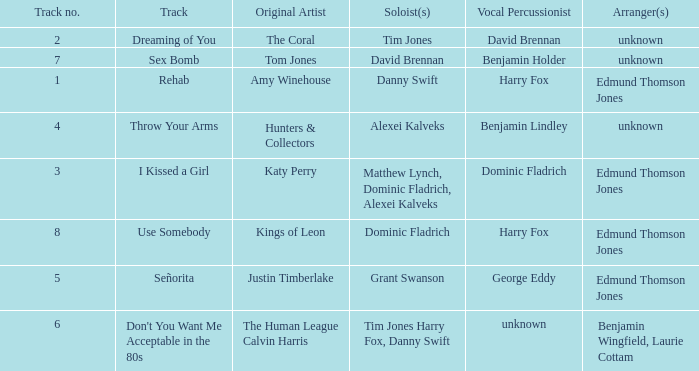Who is the percussionist for The Coral? David Brennan. 